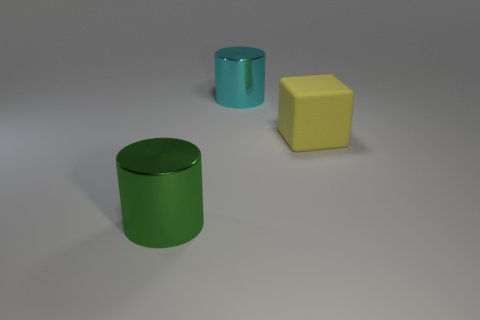If these objects were part of a larger set, what other items might you expect to see? Considering these objects, one can imagine they might be part of a children's playset or an educational tool for learning shapes and colors, so other items could include geometric shapes in various colors and materials, like spheres, cones, and cubes. 